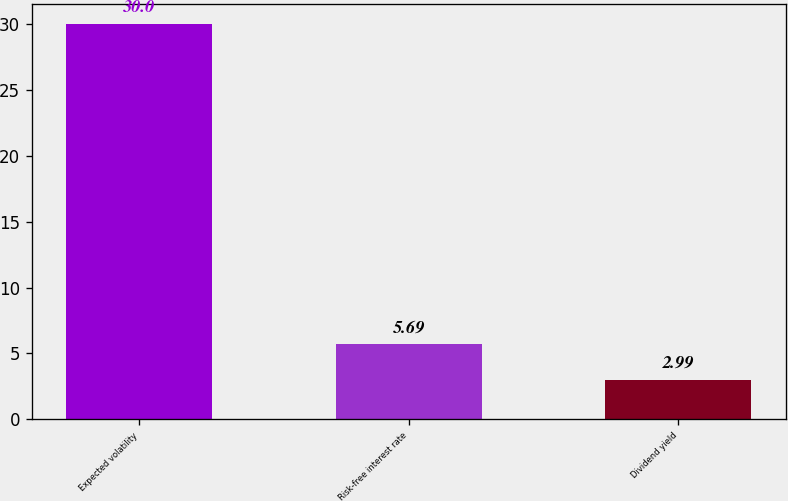Convert chart to OTSL. <chart><loc_0><loc_0><loc_500><loc_500><bar_chart><fcel>Expected volatility<fcel>Risk-free interest rate<fcel>Dividend yield<nl><fcel>30<fcel>5.69<fcel>2.99<nl></chart> 